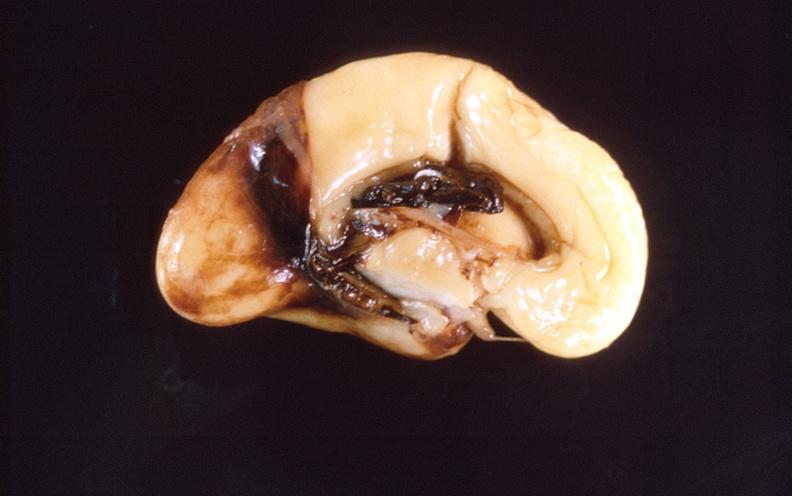s large cell lymphoma present?
Answer the question using a single word or phrase. No 